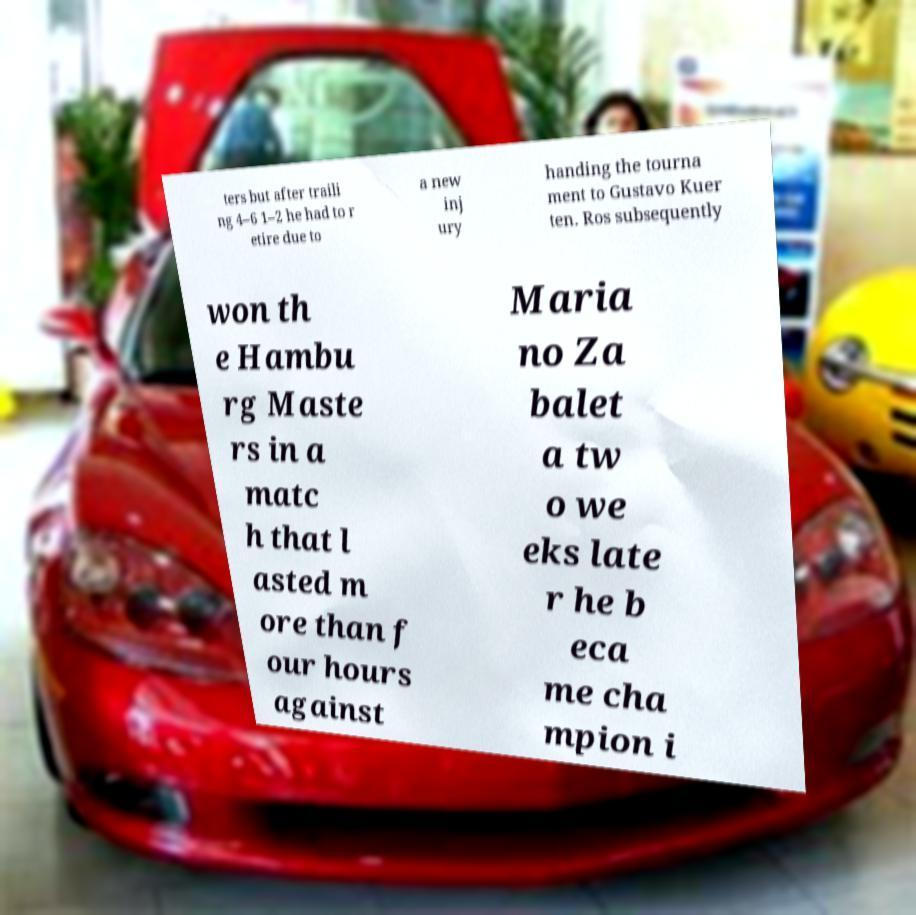Please identify and transcribe the text found in this image. ters but after traili ng 4–6 1–2 he had to r etire due to a new inj ury handing the tourna ment to Gustavo Kuer ten. Ros subsequently won th e Hambu rg Maste rs in a matc h that l asted m ore than f our hours against Maria no Za balet a tw o we eks late r he b eca me cha mpion i 